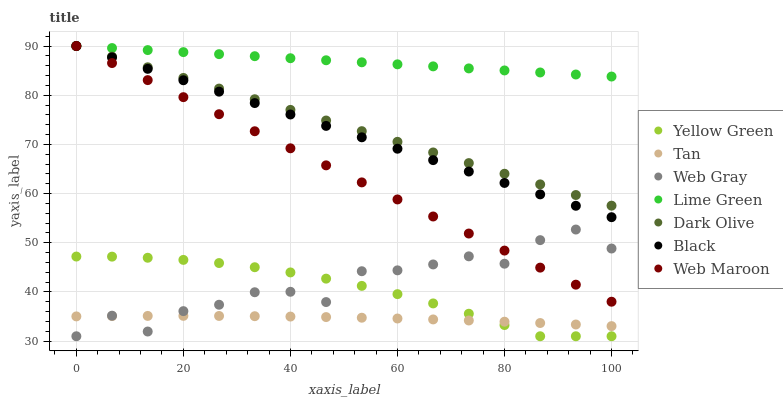Does Tan have the minimum area under the curve?
Answer yes or no. Yes. Does Lime Green have the maximum area under the curve?
Answer yes or no. Yes. Does Yellow Green have the minimum area under the curve?
Answer yes or no. No. Does Yellow Green have the maximum area under the curve?
Answer yes or no. No. Is Dark Olive the smoothest?
Answer yes or no. Yes. Is Web Gray the roughest?
Answer yes or no. Yes. Is Yellow Green the smoothest?
Answer yes or no. No. Is Yellow Green the roughest?
Answer yes or no. No. Does Web Gray have the lowest value?
Answer yes or no. Yes. Does Dark Olive have the lowest value?
Answer yes or no. No. Does Lime Green have the highest value?
Answer yes or no. Yes. Does Yellow Green have the highest value?
Answer yes or no. No. Is Yellow Green less than Web Maroon?
Answer yes or no. Yes. Is Black greater than Web Gray?
Answer yes or no. Yes. Does Tan intersect Web Gray?
Answer yes or no. Yes. Is Tan less than Web Gray?
Answer yes or no. No. Is Tan greater than Web Gray?
Answer yes or no. No. Does Yellow Green intersect Web Maroon?
Answer yes or no. No. 